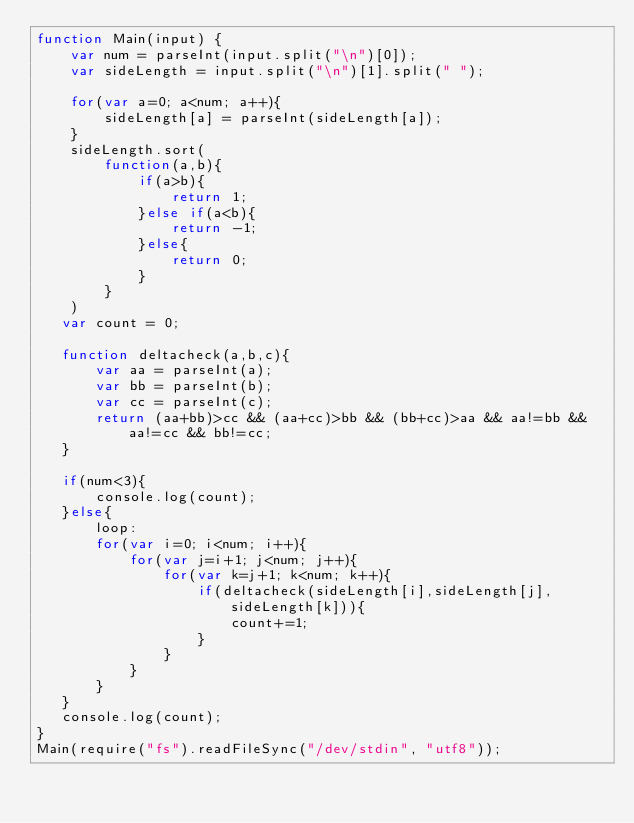Convert code to text. <code><loc_0><loc_0><loc_500><loc_500><_JavaScript_>function Main(input) {
    var num = parseInt(input.split("\n")[0]);
    var sideLength = input.split("\n")[1].split(" ");
    
    for(var a=0; a<num; a++){
        sideLength[a] = parseInt(sideLength[a]);
    }
    sideLength.sort(
        function(a,b){
            if(a>b){
                return 1;
            }else if(a<b){
                return -1;
            }else{
                return 0;
            }
        }
    )
   var count = 0;
   
   function deltacheck(a,b,c){
       var aa = parseInt(a);
       var bb = parseInt(b);
       var cc = parseInt(c);
       return (aa+bb)>cc && (aa+cc)>bb && (bb+cc)>aa && aa!=bb && aa!=cc && bb!=cc;
   }
   
   if(num<3){
       console.log(count);
   }else{
       loop:
       for(var i=0; i<num; i++){
           for(var j=i+1; j<num; j++){
               for(var k=j+1; k<num; k++){
                   if(deltacheck(sideLength[i],sideLength[j],sideLength[k])){
                       count+=1;
                   }
               }
           }
       }
   }
   console.log(count);
}
Main(require("fs").readFileSync("/dev/stdin", "utf8"));</code> 